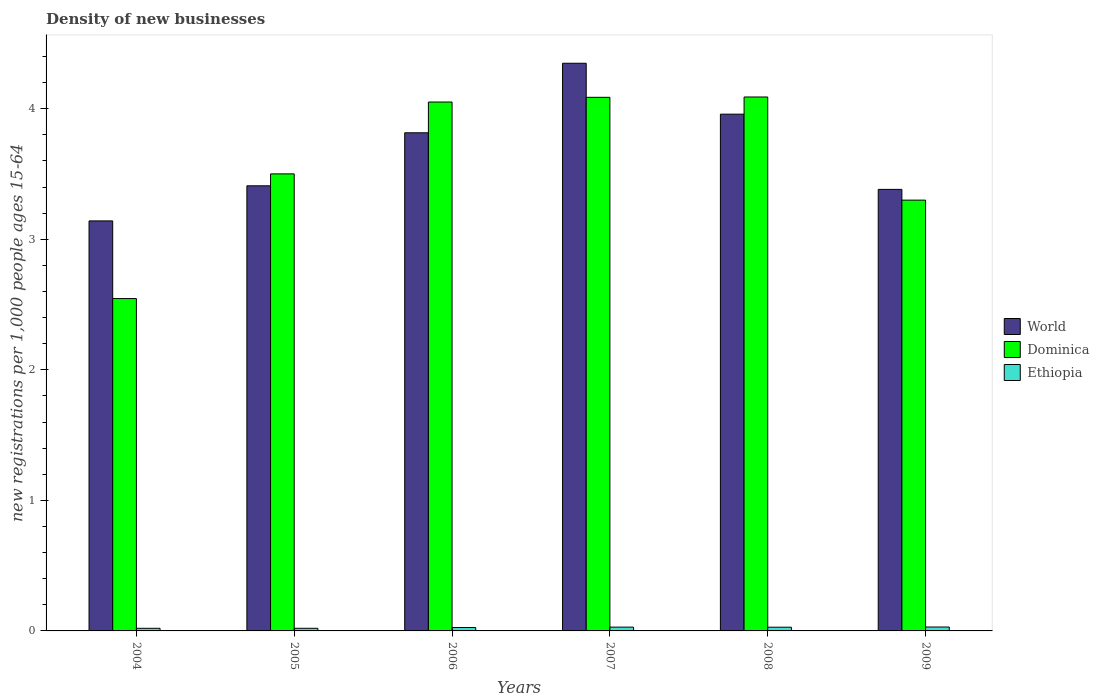How many different coloured bars are there?
Provide a succinct answer. 3. How many bars are there on the 2nd tick from the left?
Give a very brief answer. 3. How many bars are there on the 2nd tick from the right?
Your response must be concise. 3. What is the number of new registrations in World in 2009?
Give a very brief answer. 3.38. Across all years, what is the maximum number of new registrations in Dominica?
Provide a short and direct response. 4.09. Across all years, what is the minimum number of new registrations in Dominica?
Give a very brief answer. 2.55. In which year was the number of new registrations in Ethiopia minimum?
Provide a succinct answer. 2004. What is the total number of new registrations in Ethiopia in the graph?
Provide a succinct answer. 0.15. What is the difference between the number of new registrations in Ethiopia in 2005 and that in 2009?
Ensure brevity in your answer.  -0.01. What is the difference between the number of new registrations in World in 2007 and the number of new registrations in Ethiopia in 2005?
Offer a terse response. 4.33. What is the average number of new registrations in World per year?
Ensure brevity in your answer.  3.68. In the year 2007, what is the difference between the number of new registrations in World and number of new registrations in Dominica?
Give a very brief answer. 0.26. What is the ratio of the number of new registrations in Ethiopia in 2004 to that in 2005?
Provide a succinct answer. 1. Is the number of new registrations in Dominica in 2005 less than that in 2009?
Offer a terse response. No. What is the difference between the highest and the second highest number of new registrations in Dominica?
Your response must be concise. 0. What is the difference between the highest and the lowest number of new registrations in Dominica?
Keep it short and to the point. 1.54. In how many years, is the number of new registrations in World greater than the average number of new registrations in World taken over all years?
Your answer should be compact. 3. What does the 3rd bar from the left in 2004 represents?
Offer a very short reply. Ethiopia. What does the 2nd bar from the right in 2009 represents?
Give a very brief answer. Dominica. Is it the case that in every year, the sum of the number of new registrations in Dominica and number of new registrations in World is greater than the number of new registrations in Ethiopia?
Give a very brief answer. Yes. What is the difference between two consecutive major ticks on the Y-axis?
Provide a succinct answer. 1. Are the values on the major ticks of Y-axis written in scientific E-notation?
Your answer should be very brief. No. Does the graph contain any zero values?
Your answer should be very brief. No. How many legend labels are there?
Give a very brief answer. 3. How are the legend labels stacked?
Ensure brevity in your answer.  Vertical. What is the title of the graph?
Make the answer very short. Density of new businesses. What is the label or title of the Y-axis?
Your answer should be compact. New registrations per 1,0 people ages 15-64. What is the new registrations per 1,000 people ages 15-64 of World in 2004?
Provide a succinct answer. 3.14. What is the new registrations per 1,000 people ages 15-64 in Dominica in 2004?
Provide a succinct answer. 2.55. What is the new registrations per 1,000 people ages 15-64 in Ethiopia in 2004?
Give a very brief answer. 0.02. What is the new registrations per 1,000 people ages 15-64 in World in 2005?
Ensure brevity in your answer.  3.41. What is the new registrations per 1,000 people ages 15-64 in Dominica in 2005?
Provide a succinct answer. 3.5. What is the new registrations per 1,000 people ages 15-64 in Ethiopia in 2005?
Provide a succinct answer. 0.02. What is the new registrations per 1,000 people ages 15-64 of World in 2006?
Provide a short and direct response. 3.82. What is the new registrations per 1,000 people ages 15-64 in Dominica in 2006?
Give a very brief answer. 4.05. What is the new registrations per 1,000 people ages 15-64 of Ethiopia in 2006?
Your answer should be very brief. 0.03. What is the new registrations per 1,000 people ages 15-64 of World in 2007?
Your answer should be very brief. 4.35. What is the new registrations per 1,000 people ages 15-64 of Dominica in 2007?
Give a very brief answer. 4.09. What is the new registrations per 1,000 people ages 15-64 in Ethiopia in 2007?
Your response must be concise. 0.03. What is the new registrations per 1,000 people ages 15-64 of World in 2008?
Offer a terse response. 3.96. What is the new registrations per 1,000 people ages 15-64 in Dominica in 2008?
Make the answer very short. 4.09. What is the new registrations per 1,000 people ages 15-64 in Ethiopia in 2008?
Provide a short and direct response. 0.03. What is the new registrations per 1,000 people ages 15-64 in World in 2009?
Make the answer very short. 3.38. What is the new registrations per 1,000 people ages 15-64 of Dominica in 2009?
Your response must be concise. 3.3. Across all years, what is the maximum new registrations per 1,000 people ages 15-64 of World?
Provide a short and direct response. 4.35. Across all years, what is the maximum new registrations per 1,000 people ages 15-64 in Dominica?
Provide a succinct answer. 4.09. Across all years, what is the maximum new registrations per 1,000 people ages 15-64 in Ethiopia?
Ensure brevity in your answer.  0.03. Across all years, what is the minimum new registrations per 1,000 people ages 15-64 in World?
Keep it short and to the point. 3.14. Across all years, what is the minimum new registrations per 1,000 people ages 15-64 of Dominica?
Give a very brief answer. 2.55. Across all years, what is the minimum new registrations per 1,000 people ages 15-64 in Ethiopia?
Provide a short and direct response. 0.02. What is the total new registrations per 1,000 people ages 15-64 of World in the graph?
Offer a terse response. 22.06. What is the total new registrations per 1,000 people ages 15-64 in Dominica in the graph?
Provide a succinct answer. 21.58. What is the total new registrations per 1,000 people ages 15-64 in Ethiopia in the graph?
Keep it short and to the point. 0.15. What is the difference between the new registrations per 1,000 people ages 15-64 in World in 2004 and that in 2005?
Provide a succinct answer. -0.27. What is the difference between the new registrations per 1,000 people ages 15-64 in Dominica in 2004 and that in 2005?
Your response must be concise. -0.96. What is the difference between the new registrations per 1,000 people ages 15-64 of Ethiopia in 2004 and that in 2005?
Ensure brevity in your answer.  -0. What is the difference between the new registrations per 1,000 people ages 15-64 of World in 2004 and that in 2006?
Your response must be concise. -0.68. What is the difference between the new registrations per 1,000 people ages 15-64 in Dominica in 2004 and that in 2006?
Ensure brevity in your answer.  -1.51. What is the difference between the new registrations per 1,000 people ages 15-64 of Ethiopia in 2004 and that in 2006?
Offer a terse response. -0.01. What is the difference between the new registrations per 1,000 people ages 15-64 in World in 2004 and that in 2007?
Provide a succinct answer. -1.21. What is the difference between the new registrations per 1,000 people ages 15-64 in Dominica in 2004 and that in 2007?
Make the answer very short. -1.54. What is the difference between the new registrations per 1,000 people ages 15-64 in Ethiopia in 2004 and that in 2007?
Make the answer very short. -0.01. What is the difference between the new registrations per 1,000 people ages 15-64 in World in 2004 and that in 2008?
Keep it short and to the point. -0.82. What is the difference between the new registrations per 1,000 people ages 15-64 in Dominica in 2004 and that in 2008?
Make the answer very short. -1.54. What is the difference between the new registrations per 1,000 people ages 15-64 of Ethiopia in 2004 and that in 2008?
Provide a short and direct response. -0.01. What is the difference between the new registrations per 1,000 people ages 15-64 of World in 2004 and that in 2009?
Offer a very short reply. -0.24. What is the difference between the new registrations per 1,000 people ages 15-64 of Dominica in 2004 and that in 2009?
Provide a succinct answer. -0.75. What is the difference between the new registrations per 1,000 people ages 15-64 in Ethiopia in 2004 and that in 2009?
Make the answer very short. -0.01. What is the difference between the new registrations per 1,000 people ages 15-64 of World in 2005 and that in 2006?
Keep it short and to the point. -0.41. What is the difference between the new registrations per 1,000 people ages 15-64 in Dominica in 2005 and that in 2006?
Ensure brevity in your answer.  -0.55. What is the difference between the new registrations per 1,000 people ages 15-64 of Ethiopia in 2005 and that in 2006?
Provide a short and direct response. -0.01. What is the difference between the new registrations per 1,000 people ages 15-64 in World in 2005 and that in 2007?
Keep it short and to the point. -0.94. What is the difference between the new registrations per 1,000 people ages 15-64 in Dominica in 2005 and that in 2007?
Your answer should be very brief. -0.59. What is the difference between the new registrations per 1,000 people ages 15-64 in Ethiopia in 2005 and that in 2007?
Offer a terse response. -0.01. What is the difference between the new registrations per 1,000 people ages 15-64 in World in 2005 and that in 2008?
Offer a terse response. -0.55. What is the difference between the new registrations per 1,000 people ages 15-64 of Dominica in 2005 and that in 2008?
Your answer should be very brief. -0.59. What is the difference between the new registrations per 1,000 people ages 15-64 of Ethiopia in 2005 and that in 2008?
Give a very brief answer. -0.01. What is the difference between the new registrations per 1,000 people ages 15-64 of World in 2005 and that in 2009?
Your response must be concise. 0.03. What is the difference between the new registrations per 1,000 people ages 15-64 in Dominica in 2005 and that in 2009?
Your response must be concise. 0.2. What is the difference between the new registrations per 1,000 people ages 15-64 of Ethiopia in 2005 and that in 2009?
Give a very brief answer. -0.01. What is the difference between the new registrations per 1,000 people ages 15-64 in World in 2006 and that in 2007?
Offer a very short reply. -0.53. What is the difference between the new registrations per 1,000 people ages 15-64 in Dominica in 2006 and that in 2007?
Your response must be concise. -0.04. What is the difference between the new registrations per 1,000 people ages 15-64 in Ethiopia in 2006 and that in 2007?
Your response must be concise. -0. What is the difference between the new registrations per 1,000 people ages 15-64 of World in 2006 and that in 2008?
Ensure brevity in your answer.  -0.14. What is the difference between the new registrations per 1,000 people ages 15-64 in Dominica in 2006 and that in 2008?
Your answer should be very brief. -0.04. What is the difference between the new registrations per 1,000 people ages 15-64 of Ethiopia in 2006 and that in 2008?
Your answer should be compact. -0. What is the difference between the new registrations per 1,000 people ages 15-64 of World in 2006 and that in 2009?
Offer a very short reply. 0.43. What is the difference between the new registrations per 1,000 people ages 15-64 of Dominica in 2006 and that in 2009?
Your answer should be very brief. 0.75. What is the difference between the new registrations per 1,000 people ages 15-64 in Ethiopia in 2006 and that in 2009?
Give a very brief answer. -0. What is the difference between the new registrations per 1,000 people ages 15-64 of World in 2007 and that in 2008?
Offer a terse response. 0.39. What is the difference between the new registrations per 1,000 people ages 15-64 in Dominica in 2007 and that in 2008?
Your answer should be compact. -0. What is the difference between the new registrations per 1,000 people ages 15-64 of Ethiopia in 2007 and that in 2008?
Your response must be concise. 0. What is the difference between the new registrations per 1,000 people ages 15-64 in World in 2007 and that in 2009?
Your answer should be very brief. 0.97. What is the difference between the new registrations per 1,000 people ages 15-64 of Dominica in 2007 and that in 2009?
Provide a short and direct response. 0.79. What is the difference between the new registrations per 1,000 people ages 15-64 of Ethiopia in 2007 and that in 2009?
Give a very brief answer. -0. What is the difference between the new registrations per 1,000 people ages 15-64 of World in 2008 and that in 2009?
Your answer should be compact. 0.58. What is the difference between the new registrations per 1,000 people ages 15-64 of Dominica in 2008 and that in 2009?
Provide a short and direct response. 0.79. What is the difference between the new registrations per 1,000 people ages 15-64 of Ethiopia in 2008 and that in 2009?
Your answer should be very brief. -0. What is the difference between the new registrations per 1,000 people ages 15-64 of World in 2004 and the new registrations per 1,000 people ages 15-64 of Dominica in 2005?
Provide a short and direct response. -0.36. What is the difference between the new registrations per 1,000 people ages 15-64 in World in 2004 and the new registrations per 1,000 people ages 15-64 in Ethiopia in 2005?
Offer a very short reply. 3.12. What is the difference between the new registrations per 1,000 people ages 15-64 of Dominica in 2004 and the new registrations per 1,000 people ages 15-64 of Ethiopia in 2005?
Provide a succinct answer. 2.53. What is the difference between the new registrations per 1,000 people ages 15-64 of World in 2004 and the new registrations per 1,000 people ages 15-64 of Dominica in 2006?
Provide a short and direct response. -0.91. What is the difference between the new registrations per 1,000 people ages 15-64 in World in 2004 and the new registrations per 1,000 people ages 15-64 in Ethiopia in 2006?
Your response must be concise. 3.11. What is the difference between the new registrations per 1,000 people ages 15-64 in Dominica in 2004 and the new registrations per 1,000 people ages 15-64 in Ethiopia in 2006?
Provide a short and direct response. 2.52. What is the difference between the new registrations per 1,000 people ages 15-64 of World in 2004 and the new registrations per 1,000 people ages 15-64 of Dominica in 2007?
Offer a terse response. -0.95. What is the difference between the new registrations per 1,000 people ages 15-64 in World in 2004 and the new registrations per 1,000 people ages 15-64 in Ethiopia in 2007?
Your answer should be very brief. 3.11. What is the difference between the new registrations per 1,000 people ages 15-64 in Dominica in 2004 and the new registrations per 1,000 people ages 15-64 in Ethiopia in 2007?
Provide a short and direct response. 2.52. What is the difference between the new registrations per 1,000 people ages 15-64 in World in 2004 and the new registrations per 1,000 people ages 15-64 in Dominica in 2008?
Make the answer very short. -0.95. What is the difference between the new registrations per 1,000 people ages 15-64 in World in 2004 and the new registrations per 1,000 people ages 15-64 in Ethiopia in 2008?
Your response must be concise. 3.11. What is the difference between the new registrations per 1,000 people ages 15-64 in Dominica in 2004 and the new registrations per 1,000 people ages 15-64 in Ethiopia in 2008?
Provide a short and direct response. 2.52. What is the difference between the new registrations per 1,000 people ages 15-64 of World in 2004 and the new registrations per 1,000 people ages 15-64 of Dominica in 2009?
Ensure brevity in your answer.  -0.16. What is the difference between the new registrations per 1,000 people ages 15-64 in World in 2004 and the new registrations per 1,000 people ages 15-64 in Ethiopia in 2009?
Provide a short and direct response. 3.11. What is the difference between the new registrations per 1,000 people ages 15-64 in Dominica in 2004 and the new registrations per 1,000 people ages 15-64 in Ethiopia in 2009?
Offer a very short reply. 2.52. What is the difference between the new registrations per 1,000 people ages 15-64 of World in 2005 and the new registrations per 1,000 people ages 15-64 of Dominica in 2006?
Offer a terse response. -0.64. What is the difference between the new registrations per 1,000 people ages 15-64 in World in 2005 and the new registrations per 1,000 people ages 15-64 in Ethiopia in 2006?
Offer a very short reply. 3.38. What is the difference between the new registrations per 1,000 people ages 15-64 of Dominica in 2005 and the new registrations per 1,000 people ages 15-64 of Ethiopia in 2006?
Give a very brief answer. 3.48. What is the difference between the new registrations per 1,000 people ages 15-64 in World in 2005 and the new registrations per 1,000 people ages 15-64 in Dominica in 2007?
Ensure brevity in your answer.  -0.68. What is the difference between the new registrations per 1,000 people ages 15-64 of World in 2005 and the new registrations per 1,000 people ages 15-64 of Ethiopia in 2007?
Keep it short and to the point. 3.38. What is the difference between the new registrations per 1,000 people ages 15-64 in Dominica in 2005 and the new registrations per 1,000 people ages 15-64 in Ethiopia in 2007?
Keep it short and to the point. 3.47. What is the difference between the new registrations per 1,000 people ages 15-64 in World in 2005 and the new registrations per 1,000 people ages 15-64 in Dominica in 2008?
Offer a very short reply. -0.68. What is the difference between the new registrations per 1,000 people ages 15-64 in World in 2005 and the new registrations per 1,000 people ages 15-64 in Ethiopia in 2008?
Keep it short and to the point. 3.38. What is the difference between the new registrations per 1,000 people ages 15-64 of Dominica in 2005 and the new registrations per 1,000 people ages 15-64 of Ethiopia in 2008?
Your answer should be compact. 3.47. What is the difference between the new registrations per 1,000 people ages 15-64 in World in 2005 and the new registrations per 1,000 people ages 15-64 in Dominica in 2009?
Offer a very short reply. 0.11. What is the difference between the new registrations per 1,000 people ages 15-64 in World in 2005 and the new registrations per 1,000 people ages 15-64 in Ethiopia in 2009?
Make the answer very short. 3.38. What is the difference between the new registrations per 1,000 people ages 15-64 in Dominica in 2005 and the new registrations per 1,000 people ages 15-64 in Ethiopia in 2009?
Provide a succinct answer. 3.47. What is the difference between the new registrations per 1,000 people ages 15-64 of World in 2006 and the new registrations per 1,000 people ages 15-64 of Dominica in 2007?
Give a very brief answer. -0.27. What is the difference between the new registrations per 1,000 people ages 15-64 in World in 2006 and the new registrations per 1,000 people ages 15-64 in Ethiopia in 2007?
Give a very brief answer. 3.79. What is the difference between the new registrations per 1,000 people ages 15-64 in Dominica in 2006 and the new registrations per 1,000 people ages 15-64 in Ethiopia in 2007?
Your answer should be compact. 4.02. What is the difference between the new registrations per 1,000 people ages 15-64 of World in 2006 and the new registrations per 1,000 people ages 15-64 of Dominica in 2008?
Offer a terse response. -0.27. What is the difference between the new registrations per 1,000 people ages 15-64 of World in 2006 and the new registrations per 1,000 people ages 15-64 of Ethiopia in 2008?
Your answer should be very brief. 3.79. What is the difference between the new registrations per 1,000 people ages 15-64 in Dominica in 2006 and the new registrations per 1,000 people ages 15-64 in Ethiopia in 2008?
Your answer should be compact. 4.02. What is the difference between the new registrations per 1,000 people ages 15-64 of World in 2006 and the new registrations per 1,000 people ages 15-64 of Dominica in 2009?
Keep it short and to the point. 0.52. What is the difference between the new registrations per 1,000 people ages 15-64 of World in 2006 and the new registrations per 1,000 people ages 15-64 of Ethiopia in 2009?
Your response must be concise. 3.79. What is the difference between the new registrations per 1,000 people ages 15-64 in Dominica in 2006 and the new registrations per 1,000 people ages 15-64 in Ethiopia in 2009?
Provide a succinct answer. 4.02. What is the difference between the new registrations per 1,000 people ages 15-64 in World in 2007 and the new registrations per 1,000 people ages 15-64 in Dominica in 2008?
Offer a terse response. 0.26. What is the difference between the new registrations per 1,000 people ages 15-64 in World in 2007 and the new registrations per 1,000 people ages 15-64 in Ethiopia in 2008?
Your response must be concise. 4.32. What is the difference between the new registrations per 1,000 people ages 15-64 in Dominica in 2007 and the new registrations per 1,000 people ages 15-64 in Ethiopia in 2008?
Offer a very short reply. 4.06. What is the difference between the new registrations per 1,000 people ages 15-64 of World in 2007 and the new registrations per 1,000 people ages 15-64 of Dominica in 2009?
Give a very brief answer. 1.05. What is the difference between the new registrations per 1,000 people ages 15-64 in World in 2007 and the new registrations per 1,000 people ages 15-64 in Ethiopia in 2009?
Your answer should be very brief. 4.32. What is the difference between the new registrations per 1,000 people ages 15-64 of Dominica in 2007 and the new registrations per 1,000 people ages 15-64 of Ethiopia in 2009?
Provide a succinct answer. 4.06. What is the difference between the new registrations per 1,000 people ages 15-64 of World in 2008 and the new registrations per 1,000 people ages 15-64 of Dominica in 2009?
Offer a very short reply. 0.66. What is the difference between the new registrations per 1,000 people ages 15-64 of World in 2008 and the new registrations per 1,000 people ages 15-64 of Ethiopia in 2009?
Give a very brief answer. 3.93. What is the difference between the new registrations per 1,000 people ages 15-64 in Dominica in 2008 and the new registrations per 1,000 people ages 15-64 in Ethiopia in 2009?
Your response must be concise. 4.06. What is the average new registrations per 1,000 people ages 15-64 of World per year?
Make the answer very short. 3.68. What is the average new registrations per 1,000 people ages 15-64 in Dominica per year?
Provide a short and direct response. 3.6. What is the average new registrations per 1,000 people ages 15-64 in Ethiopia per year?
Provide a succinct answer. 0.03. In the year 2004, what is the difference between the new registrations per 1,000 people ages 15-64 in World and new registrations per 1,000 people ages 15-64 in Dominica?
Offer a very short reply. 0.59. In the year 2004, what is the difference between the new registrations per 1,000 people ages 15-64 in World and new registrations per 1,000 people ages 15-64 in Ethiopia?
Provide a short and direct response. 3.12. In the year 2004, what is the difference between the new registrations per 1,000 people ages 15-64 in Dominica and new registrations per 1,000 people ages 15-64 in Ethiopia?
Offer a very short reply. 2.53. In the year 2005, what is the difference between the new registrations per 1,000 people ages 15-64 in World and new registrations per 1,000 people ages 15-64 in Dominica?
Keep it short and to the point. -0.09. In the year 2005, what is the difference between the new registrations per 1,000 people ages 15-64 in World and new registrations per 1,000 people ages 15-64 in Ethiopia?
Your answer should be very brief. 3.39. In the year 2005, what is the difference between the new registrations per 1,000 people ages 15-64 in Dominica and new registrations per 1,000 people ages 15-64 in Ethiopia?
Offer a very short reply. 3.48. In the year 2006, what is the difference between the new registrations per 1,000 people ages 15-64 in World and new registrations per 1,000 people ages 15-64 in Dominica?
Provide a succinct answer. -0.24. In the year 2006, what is the difference between the new registrations per 1,000 people ages 15-64 in World and new registrations per 1,000 people ages 15-64 in Ethiopia?
Your response must be concise. 3.79. In the year 2006, what is the difference between the new registrations per 1,000 people ages 15-64 of Dominica and new registrations per 1,000 people ages 15-64 of Ethiopia?
Provide a succinct answer. 4.03. In the year 2007, what is the difference between the new registrations per 1,000 people ages 15-64 in World and new registrations per 1,000 people ages 15-64 in Dominica?
Offer a very short reply. 0.26. In the year 2007, what is the difference between the new registrations per 1,000 people ages 15-64 of World and new registrations per 1,000 people ages 15-64 of Ethiopia?
Provide a succinct answer. 4.32. In the year 2007, what is the difference between the new registrations per 1,000 people ages 15-64 of Dominica and new registrations per 1,000 people ages 15-64 of Ethiopia?
Your answer should be compact. 4.06. In the year 2008, what is the difference between the new registrations per 1,000 people ages 15-64 of World and new registrations per 1,000 people ages 15-64 of Dominica?
Offer a terse response. -0.13. In the year 2008, what is the difference between the new registrations per 1,000 people ages 15-64 of World and new registrations per 1,000 people ages 15-64 of Ethiopia?
Give a very brief answer. 3.93. In the year 2008, what is the difference between the new registrations per 1,000 people ages 15-64 in Dominica and new registrations per 1,000 people ages 15-64 in Ethiopia?
Your response must be concise. 4.06. In the year 2009, what is the difference between the new registrations per 1,000 people ages 15-64 in World and new registrations per 1,000 people ages 15-64 in Dominica?
Offer a very short reply. 0.08. In the year 2009, what is the difference between the new registrations per 1,000 people ages 15-64 in World and new registrations per 1,000 people ages 15-64 in Ethiopia?
Make the answer very short. 3.35. In the year 2009, what is the difference between the new registrations per 1,000 people ages 15-64 of Dominica and new registrations per 1,000 people ages 15-64 of Ethiopia?
Offer a very short reply. 3.27. What is the ratio of the new registrations per 1,000 people ages 15-64 in World in 2004 to that in 2005?
Make the answer very short. 0.92. What is the ratio of the new registrations per 1,000 people ages 15-64 of Dominica in 2004 to that in 2005?
Make the answer very short. 0.73. What is the ratio of the new registrations per 1,000 people ages 15-64 in Ethiopia in 2004 to that in 2005?
Your answer should be compact. 1. What is the ratio of the new registrations per 1,000 people ages 15-64 in World in 2004 to that in 2006?
Ensure brevity in your answer.  0.82. What is the ratio of the new registrations per 1,000 people ages 15-64 of Dominica in 2004 to that in 2006?
Your answer should be very brief. 0.63. What is the ratio of the new registrations per 1,000 people ages 15-64 in Ethiopia in 2004 to that in 2006?
Keep it short and to the point. 0.77. What is the ratio of the new registrations per 1,000 people ages 15-64 of World in 2004 to that in 2007?
Your response must be concise. 0.72. What is the ratio of the new registrations per 1,000 people ages 15-64 in Dominica in 2004 to that in 2007?
Keep it short and to the point. 0.62. What is the ratio of the new registrations per 1,000 people ages 15-64 of Ethiopia in 2004 to that in 2007?
Your response must be concise. 0.69. What is the ratio of the new registrations per 1,000 people ages 15-64 in World in 2004 to that in 2008?
Offer a very short reply. 0.79. What is the ratio of the new registrations per 1,000 people ages 15-64 in Dominica in 2004 to that in 2008?
Offer a terse response. 0.62. What is the ratio of the new registrations per 1,000 people ages 15-64 of Ethiopia in 2004 to that in 2008?
Offer a terse response. 0.71. What is the ratio of the new registrations per 1,000 people ages 15-64 of World in 2004 to that in 2009?
Ensure brevity in your answer.  0.93. What is the ratio of the new registrations per 1,000 people ages 15-64 of Dominica in 2004 to that in 2009?
Keep it short and to the point. 0.77. What is the ratio of the new registrations per 1,000 people ages 15-64 of Ethiopia in 2004 to that in 2009?
Offer a very short reply. 0.67. What is the ratio of the new registrations per 1,000 people ages 15-64 in World in 2005 to that in 2006?
Keep it short and to the point. 0.89. What is the ratio of the new registrations per 1,000 people ages 15-64 of Dominica in 2005 to that in 2006?
Offer a very short reply. 0.86. What is the ratio of the new registrations per 1,000 people ages 15-64 in Ethiopia in 2005 to that in 2006?
Offer a terse response. 0.77. What is the ratio of the new registrations per 1,000 people ages 15-64 of World in 2005 to that in 2007?
Give a very brief answer. 0.78. What is the ratio of the new registrations per 1,000 people ages 15-64 in Dominica in 2005 to that in 2007?
Ensure brevity in your answer.  0.86. What is the ratio of the new registrations per 1,000 people ages 15-64 of Ethiopia in 2005 to that in 2007?
Provide a succinct answer. 0.69. What is the ratio of the new registrations per 1,000 people ages 15-64 in World in 2005 to that in 2008?
Provide a succinct answer. 0.86. What is the ratio of the new registrations per 1,000 people ages 15-64 in Dominica in 2005 to that in 2008?
Offer a very short reply. 0.86. What is the ratio of the new registrations per 1,000 people ages 15-64 of Ethiopia in 2005 to that in 2008?
Provide a short and direct response. 0.71. What is the ratio of the new registrations per 1,000 people ages 15-64 of World in 2005 to that in 2009?
Offer a terse response. 1.01. What is the ratio of the new registrations per 1,000 people ages 15-64 in Dominica in 2005 to that in 2009?
Provide a succinct answer. 1.06. What is the ratio of the new registrations per 1,000 people ages 15-64 of Ethiopia in 2005 to that in 2009?
Give a very brief answer. 0.67. What is the ratio of the new registrations per 1,000 people ages 15-64 in World in 2006 to that in 2007?
Ensure brevity in your answer.  0.88. What is the ratio of the new registrations per 1,000 people ages 15-64 of Dominica in 2006 to that in 2007?
Your answer should be compact. 0.99. What is the ratio of the new registrations per 1,000 people ages 15-64 of Ethiopia in 2006 to that in 2007?
Offer a terse response. 0.9. What is the ratio of the new registrations per 1,000 people ages 15-64 of Dominica in 2006 to that in 2008?
Make the answer very short. 0.99. What is the ratio of the new registrations per 1,000 people ages 15-64 of Ethiopia in 2006 to that in 2008?
Offer a very short reply. 0.91. What is the ratio of the new registrations per 1,000 people ages 15-64 of World in 2006 to that in 2009?
Provide a short and direct response. 1.13. What is the ratio of the new registrations per 1,000 people ages 15-64 in Dominica in 2006 to that in 2009?
Ensure brevity in your answer.  1.23. What is the ratio of the new registrations per 1,000 people ages 15-64 of Ethiopia in 2006 to that in 2009?
Make the answer very short. 0.87. What is the ratio of the new registrations per 1,000 people ages 15-64 in World in 2007 to that in 2008?
Keep it short and to the point. 1.1. What is the ratio of the new registrations per 1,000 people ages 15-64 in Ethiopia in 2007 to that in 2008?
Offer a very short reply. 1.02. What is the ratio of the new registrations per 1,000 people ages 15-64 in World in 2007 to that in 2009?
Your response must be concise. 1.29. What is the ratio of the new registrations per 1,000 people ages 15-64 in Dominica in 2007 to that in 2009?
Provide a succinct answer. 1.24. What is the ratio of the new registrations per 1,000 people ages 15-64 of Ethiopia in 2007 to that in 2009?
Offer a terse response. 0.97. What is the ratio of the new registrations per 1,000 people ages 15-64 of World in 2008 to that in 2009?
Your response must be concise. 1.17. What is the ratio of the new registrations per 1,000 people ages 15-64 of Dominica in 2008 to that in 2009?
Offer a terse response. 1.24. What is the ratio of the new registrations per 1,000 people ages 15-64 in Ethiopia in 2008 to that in 2009?
Keep it short and to the point. 0.95. What is the difference between the highest and the second highest new registrations per 1,000 people ages 15-64 of World?
Make the answer very short. 0.39. What is the difference between the highest and the second highest new registrations per 1,000 people ages 15-64 in Dominica?
Ensure brevity in your answer.  0. What is the difference between the highest and the second highest new registrations per 1,000 people ages 15-64 of Ethiopia?
Keep it short and to the point. 0. What is the difference between the highest and the lowest new registrations per 1,000 people ages 15-64 in World?
Make the answer very short. 1.21. What is the difference between the highest and the lowest new registrations per 1,000 people ages 15-64 of Dominica?
Keep it short and to the point. 1.54. What is the difference between the highest and the lowest new registrations per 1,000 people ages 15-64 in Ethiopia?
Give a very brief answer. 0.01. 